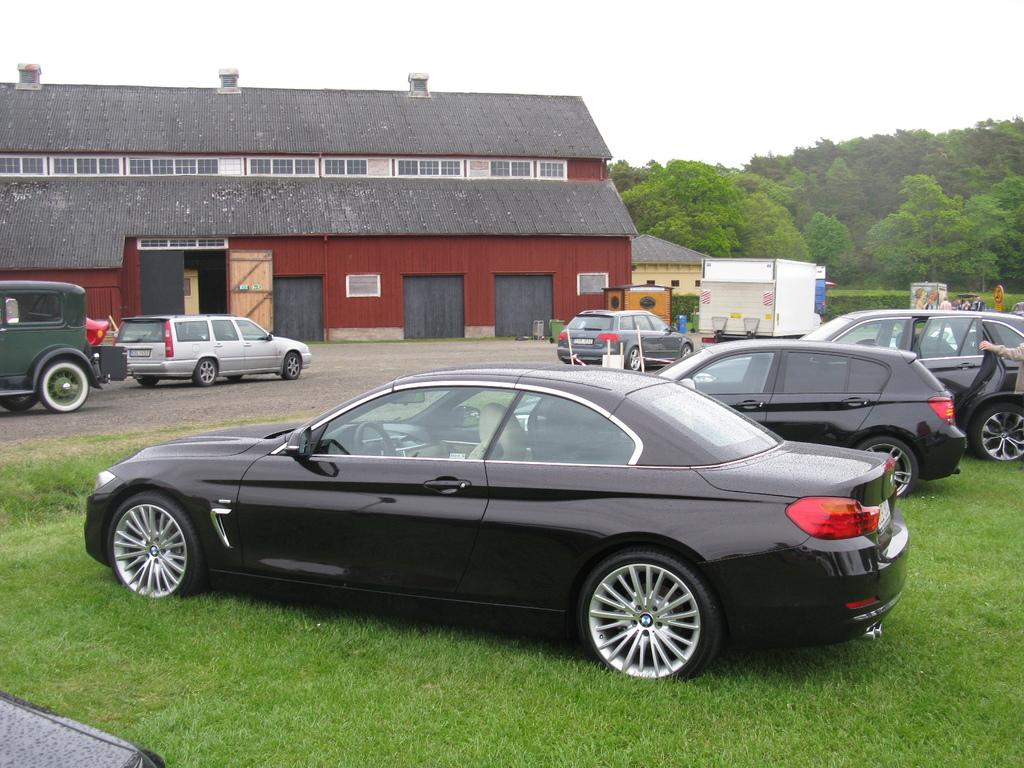What type of vehicles can be seen on the grassland in the image? There are cars on the grassland in the image. Where are more vehicles located in the image? There is a godown with vehicles in the image. Can you describe the location of the godown? The godown is located on the road. What can be seen on the right side of the image? There are trees on the right side of the image. What is visible above the trees in the image? The sky is visible above the trees. What type of tools does the carpenter use in the image? There is no carpenter present in the image, so no tools can be observed. What emotion is the hope depicted as in the image? There is no emotion or personification of hope in the image; it is a scene with cars, a godown, trees, and the sky. 